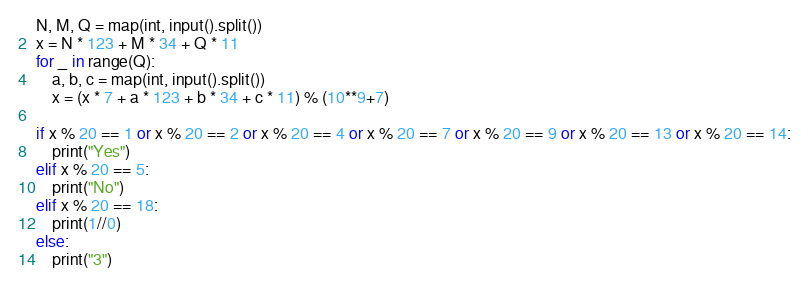Convert code to text. <code><loc_0><loc_0><loc_500><loc_500><_Python_>N, M, Q = map(int, input().split())
x = N * 123 + M * 34 + Q * 11
for _ in range(Q):
    a, b, c = map(int, input().split())
    x = (x * 7 + a * 123 + b * 34 + c * 11) % (10**9+7)

if x % 20 == 1 or x % 20 == 2 or x % 20 == 4 or x % 20 == 7 or x % 20 == 9 or x % 20 == 13 or x % 20 == 14:
    print("Yes")
elif x % 20 == 5:
    print("No")
elif x % 20 == 18:
    print(1//0)
else:
    print("3")
</code> 